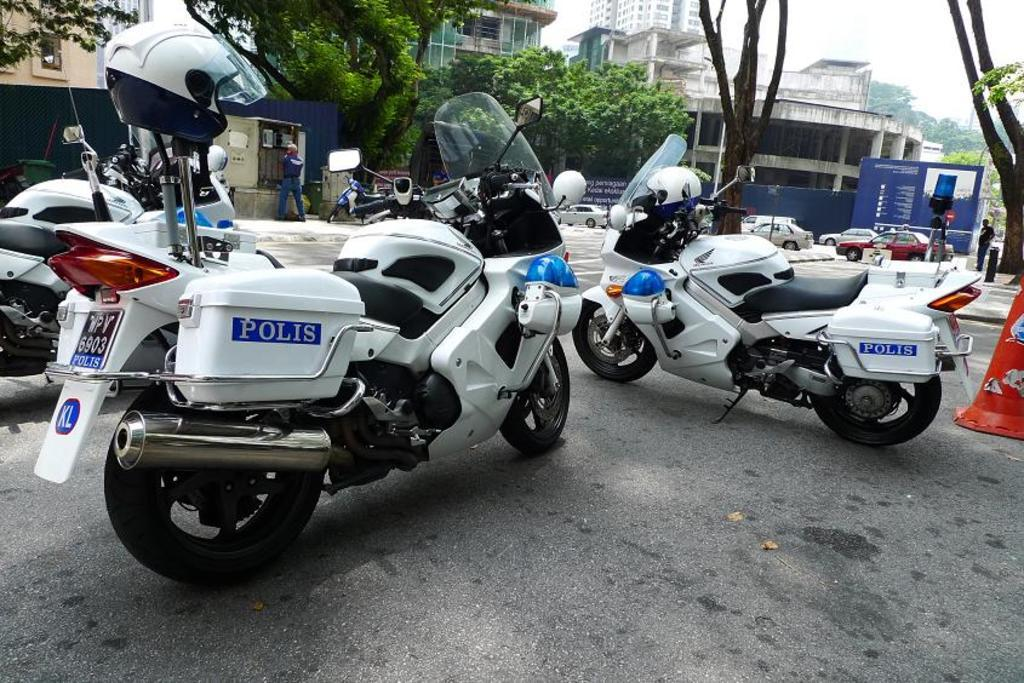What type of vehicles are present in the image? There are motorcycles and cars in the image. What else can be seen in the image besides vehicles? There are trees and buildings in the image. What is visible in the background of the image? The sky is visible in the image. What type of care is being provided to the trees in the image? There is no indication of any care being provided to the trees in the image; they are simply present in the scene. Can you see a yoke or kettle in the image? No, there is no yoke or kettle present in the image. 